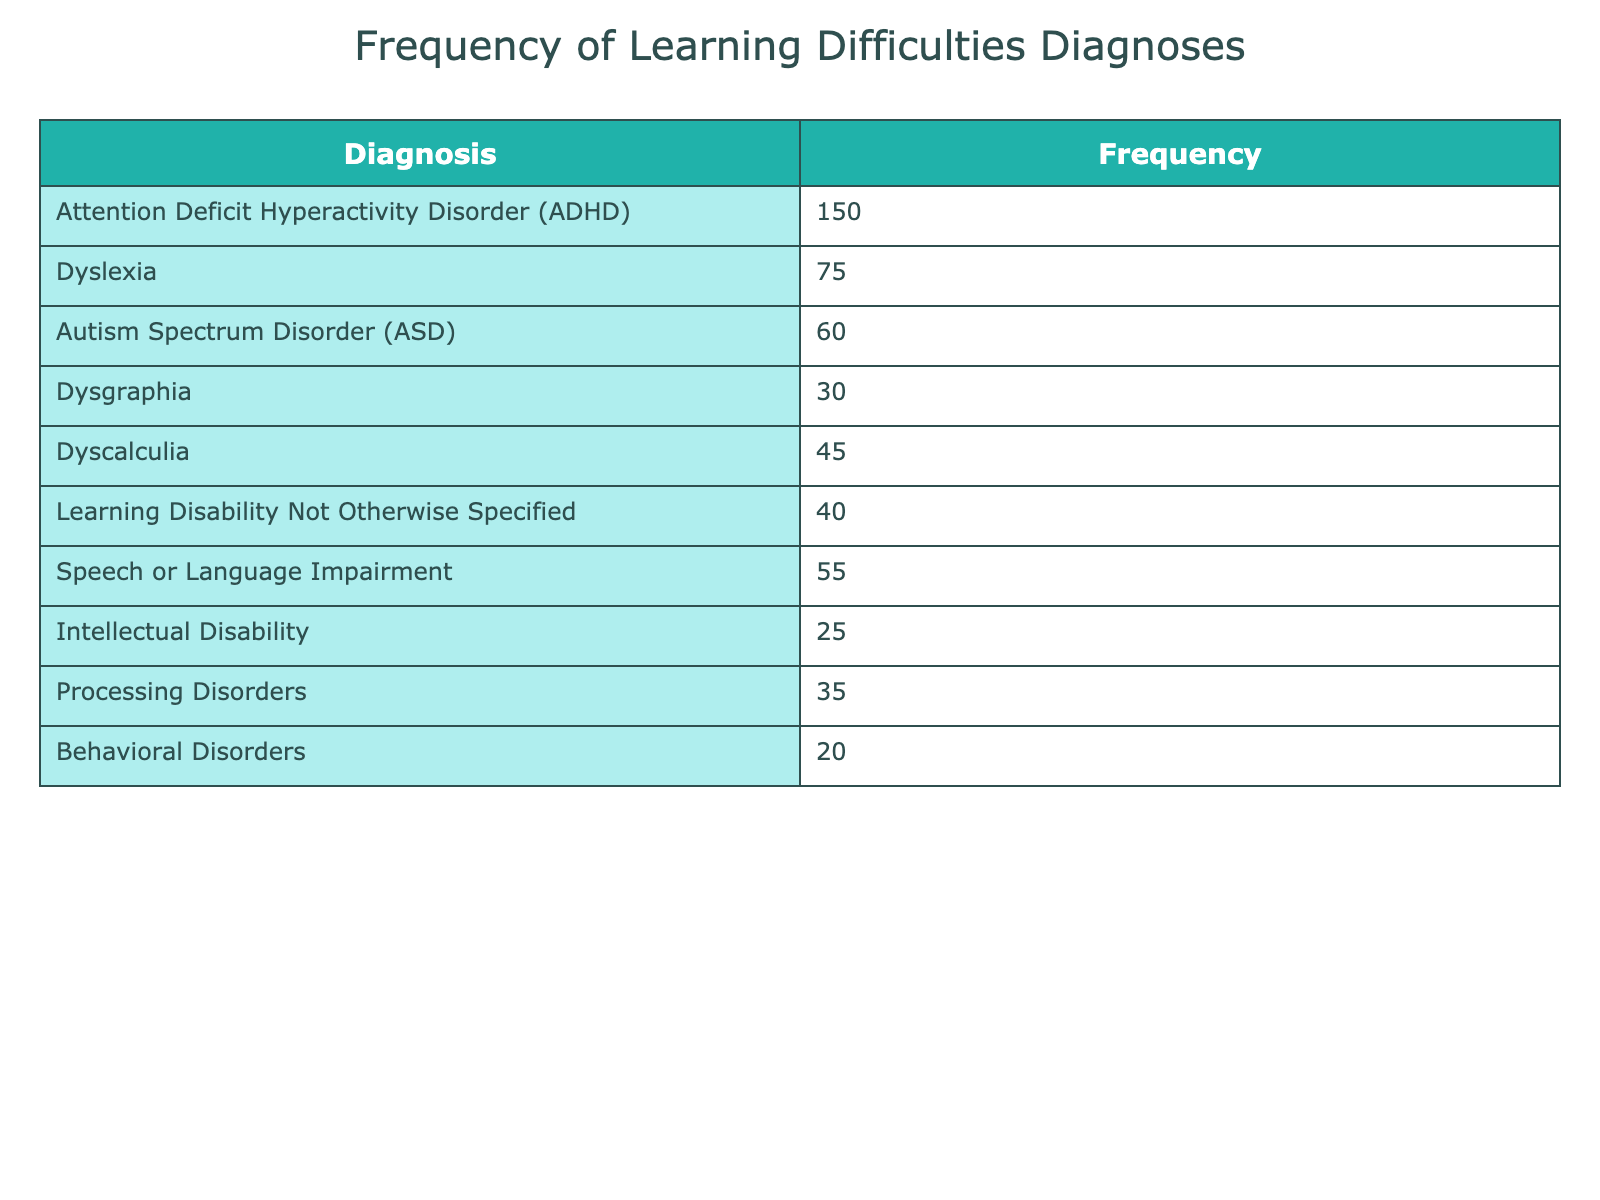What is the frequency of Attention Deficit Hyperactivity Disorder (ADHD) diagnoses? The table indicates that the frequency of ADHD diagnoses is directly listed under the "Frequency" column corresponding to ADHD in the "Diagnosis" column. That value is 150.
Answer: 150 How many diagnoses are less frequent than Dyscalculia? Dyscalculia has a frequency of 45. By examining the table, the diagnoses with a frequency less than 45 are Dysgraphia (30), Intellectual Disability (25), and Behavioral Disorders (20). Adding these frequencies gives 30 + 25 + 20 = 75.
Answer: 75 What is the sum of frequencies for all diagnoses? To calculate the total frequency, we need to sum each frequency listed in the table. The frequencies are: 150 (ADHD) + 75 (Dyslexia) + 60 (ASD) + 30 (Dysgraphia) + 45 (Dyscalculia) + 40 (Learning Disability Not Otherwise Specified) + 55 (Speech or Language Impairment) + 25 (Intellectual Disability) + 35 (Processing Disorders) + 20 (Behavioral Disorders). Adding them all gives a total of 150 + 75 + 60 + 30 + 45 + 40 + 55 + 25 + 35 + 20 = 560.
Answer: 560 Are there more cases of Speech or Language Impairment than Intellectual Disability? Looking at the table, Speech or Language Impairment has a frequency of 55 while Intellectual Disability has a frequency of 25. Since 55 is greater than 25, the answer is yes.
Answer: Yes What is the average frequency of all the diagnoses listed? To find the average frequency, sum the frequencies (560, as calculated previously) and divide it by the number of diagnoses. There are 10 different diagnoses in the table. Dividing the total frequency by the number of diagnoses gives 560 / 10 = 56.
Answer: 56 Which diagnosis has the least frequency and what is that frequency? Reviewing the "Frequency" column of the table, the least frequency is observed for Behavioral Disorders, which has a frequency of 20.
Answer: 20 How many more cases of Dyslexia are there compared to Processing Disorders? From the table, Dyslexia has a frequency of 75 while Processing Disorders has a frequency of 35. To find the difference, subtract 35 from 75, giving 75 - 35 = 40.
Answer: 40 Count the number of diagnoses that have a frequency of 50 or more. According to the table, the diagnoses with a frequency of 50 or more are ADHD (150), Dyslexia (75), ASD (60), and Speech or Language Impairment (55). Counting these gives a total of 4 diagnoses.
Answer: 4 